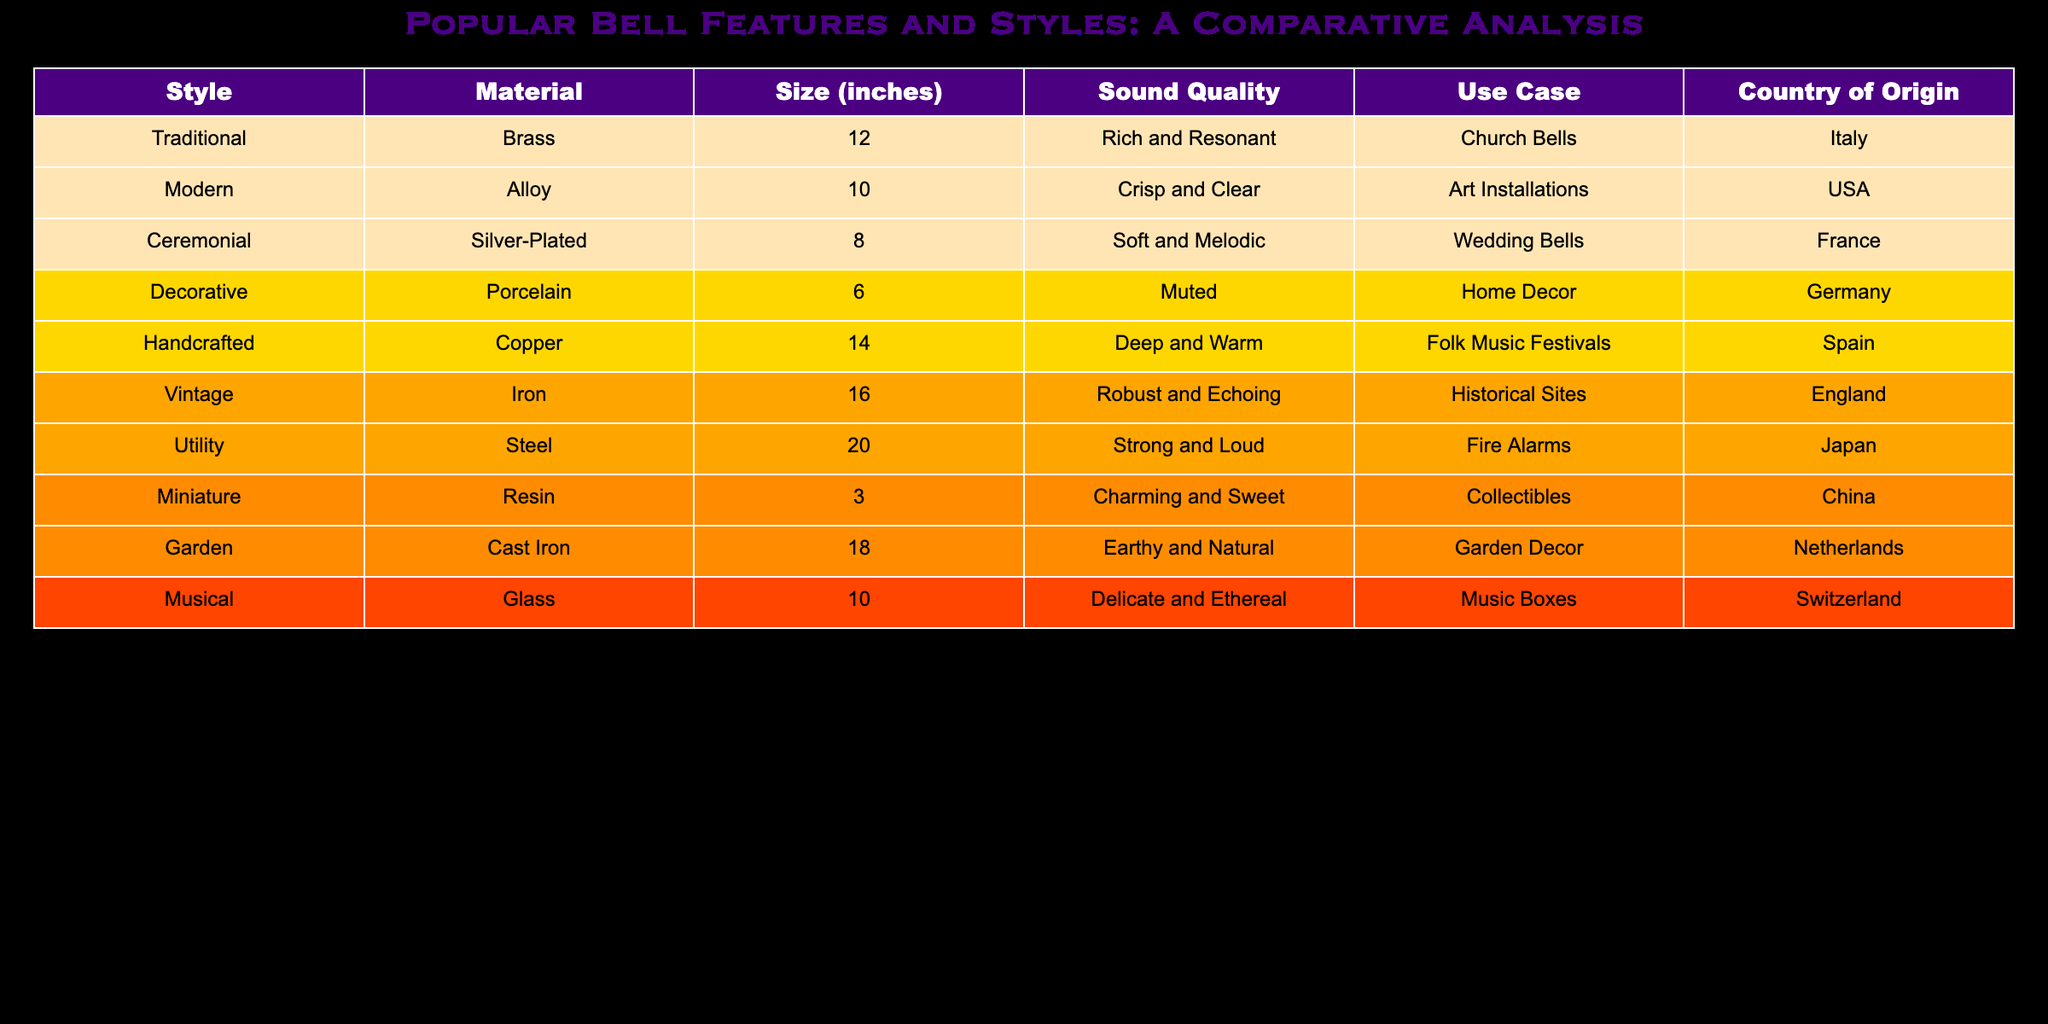What is the size of the Traditional bell? According to the table, the size of the Traditional bell is listed under the "Size (inches)" column as 12 inches.
Answer: 12 inches Which material is used for the Ceremonial bell? The table specifies that the material used for the Ceremonial bell is Silver-Plated, found in the "Material" column.
Answer: Silver-Plated How many bells are made from brass? By examining the table, only the Traditional bell is made from brass, as indicated in the "Material" column.
Answer: 1 Is the Sound Quality of the Vintage bell described as 'Soft and Melodic'? The table lists the sound quality of the Vintage bell as 'Robust and Echoing', confirming that it is not 'Soft and Melodic'.
Answer: No What is the average size of bells from the USA and Italy? The sizes of the bells from these countries are 10 inches (USA) for the Modern bell and 12 inches (Italy) for the Traditional bell. Adding these gives a total of 22 inches, and dividing by 2 (the number of bells) results in an average of 11 inches.
Answer: 11 inches Which country of origin has a Decorative bell? By checking the table, it is evident that the country of origin for the Decorative bell is Germany, noted in the "Country of Origin" column.
Answer: Germany How many bells have a Sound Quality described as 'Deep and Warm'? The Handcrafted bell is the only one categorized as having a 'Deep and Warm' sound quality, based on the data in the table.
Answer: 1 Do all the bells in the table have a size greater than 5 inches? The Miniature bell is listed with a size of 3 inches, which shows that not all bells exceed 5 inches.
Answer: No What is the highest sound quality described in the table? The Vintage bell has the highest sound quality described as 'Robust and Echoing', which can be verified from the "Sound Quality" column.
Answer: Robust and Echoing 